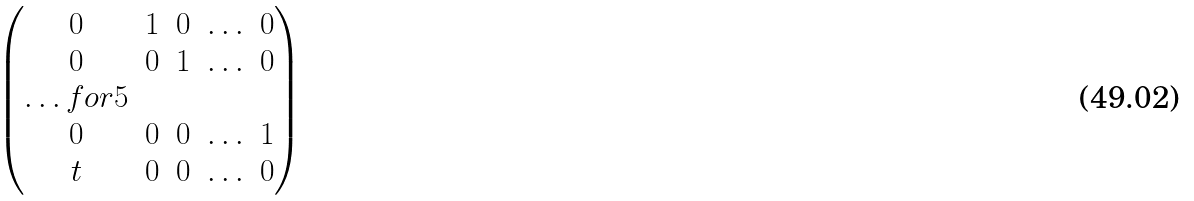Convert formula to latex. <formula><loc_0><loc_0><loc_500><loc_500>\begin{pmatrix} 0 & 1 & 0 & \hdots & 0 \\ 0 & 0 & 1 & \hdots & 0 \\ \hdots f o r { 5 } \\ 0 & 0 & 0 & \hdots & 1 \\ t & 0 & 0 & \hdots & 0 \end{pmatrix}</formula> 